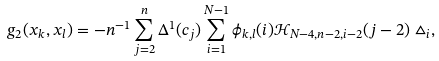Convert formula to latex. <formula><loc_0><loc_0><loc_500><loc_500>g _ { 2 } ( x _ { k } , x _ { l } ) = - n ^ { - 1 } \sum _ { j = 2 } ^ { n } \Delta ^ { 1 } ( c _ { j } ) \sum _ { i = 1 } ^ { N - 1 } \phi _ { k , l } ( i ) \mathcal { H } _ { N - 4 , n - 2 , i - 2 } ( j - 2 ) \vartriangle _ { i } ,</formula> 